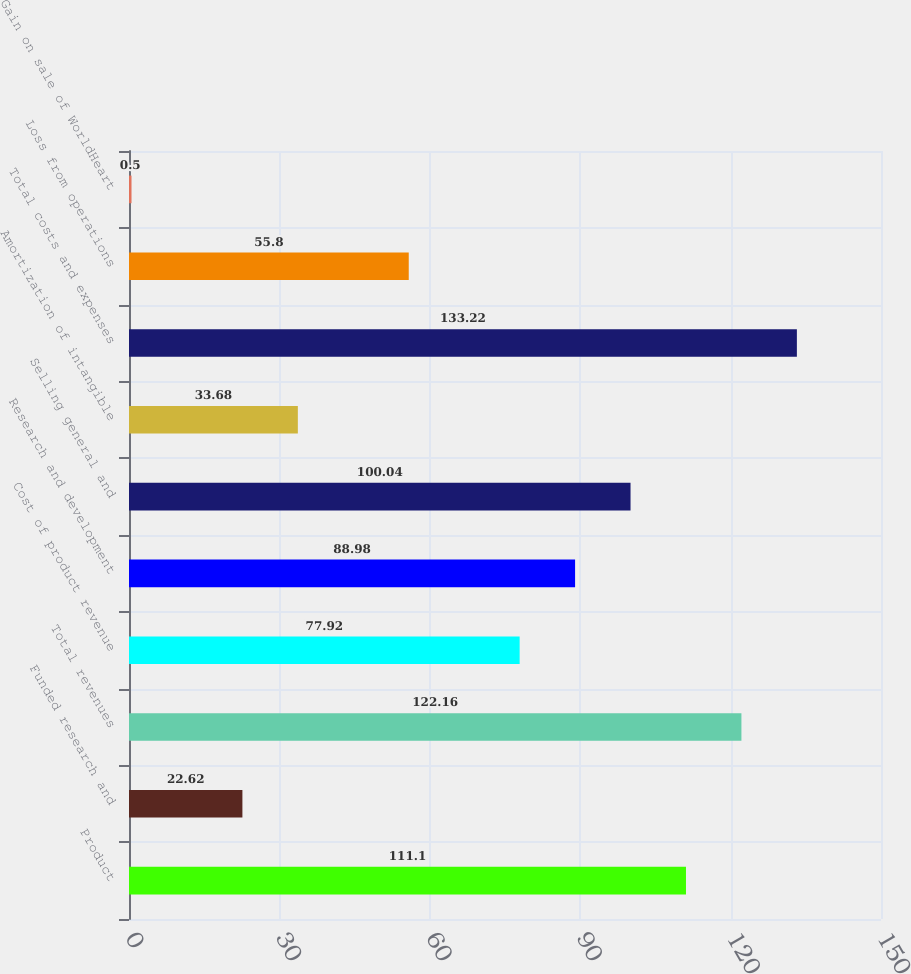<chart> <loc_0><loc_0><loc_500><loc_500><bar_chart><fcel>Product<fcel>Funded research and<fcel>Total revenues<fcel>Cost of product revenue<fcel>Research and development<fcel>Selling general and<fcel>Amortization of intangible<fcel>Total costs and expenses<fcel>Loss from operations<fcel>Gain on sale of WorldHeart<nl><fcel>111.1<fcel>22.62<fcel>122.16<fcel>77.92<fcel>88.98<fcel>100.04<fcel>33.68<fcel>133.22<fcel>55.8<fcel>0.5<nl></chart> 